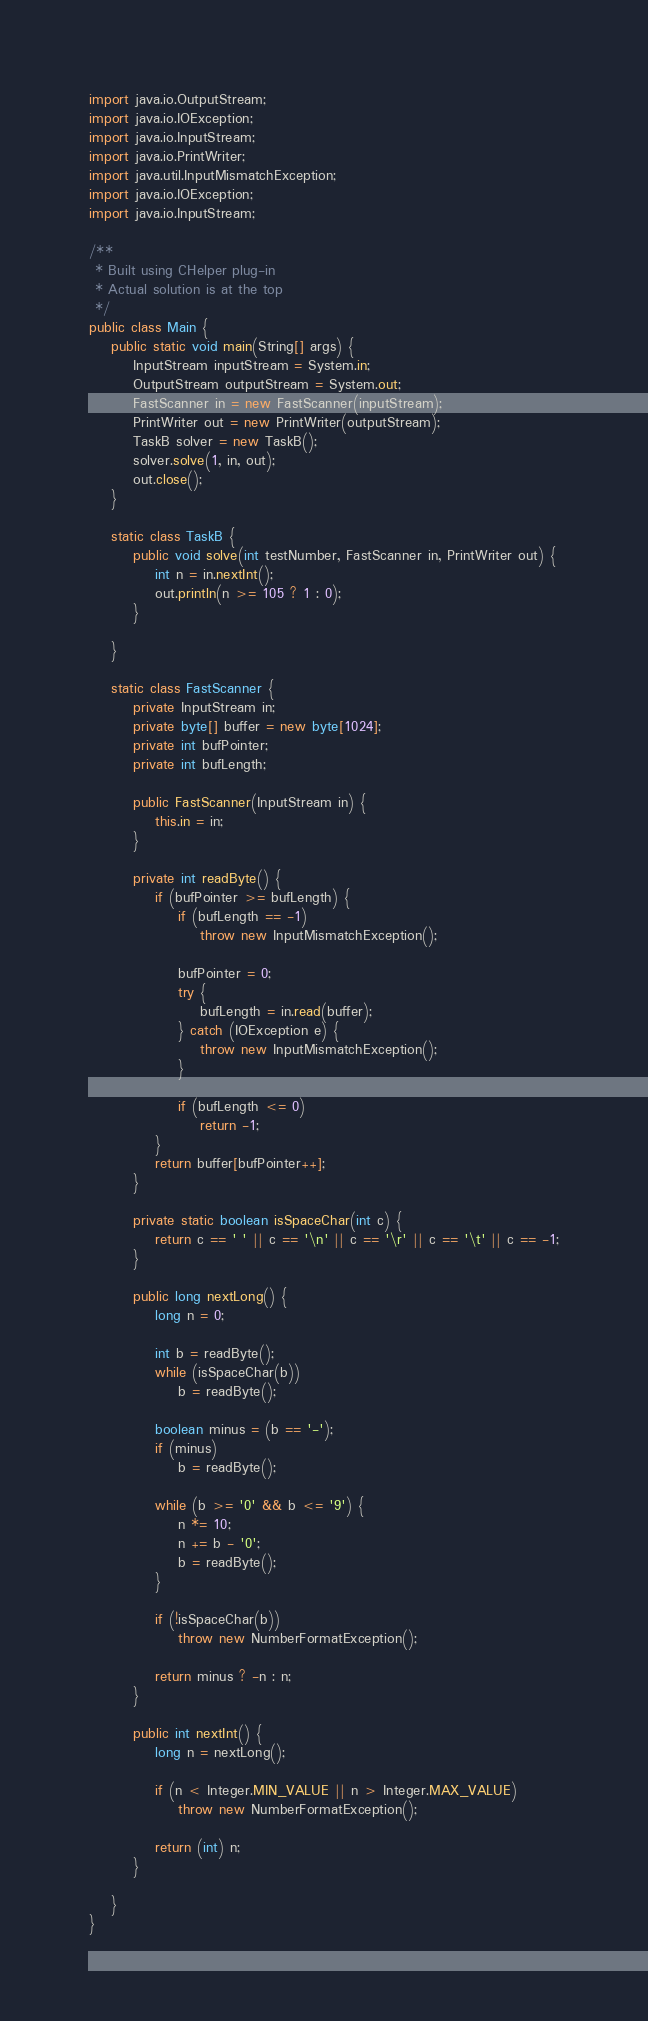Convert code to text. <code><loc_0><loc_0><loc_500><loc_500><_Java_>import java.io.OutputStream;
import java.io.IOException;
import java.io.InputStream;
import java.io.PrintWriter;
import java.util.InputMismatchException;
import java.io.IOException;
import java.io.InputStream;

/**
 * Built using CHelper plug-in
 * Actual solution is at the top
 */
public class Main {
    public static void main(String[] args) {
        InputStream inputStream = System.in;
        OutputStream outputStream = System.out;
        FastScanner in = new FastScanner(inputStream);
        PrintWriter out = new PrintWriter(outputStream);
        TaskB solver = new TaskB();
        solver.solve(1, in, out);
        out.close();
    }

    static class TaskB {
        public void solve(int testNumber, FastScanner in, PrintWriter out) {
            int n = in.nextInt();
            out.println(n >= 105 ? 1 : 0);
        }

    }

    static class FastScanner {
        private InputStream in;
        private byte[] buffer = new byte[1024];
        private int bufPointer;
        private int bufLength;

        public FastScanner(InputStream in) {
            this.in = in;
        }

        private int readByte() {
            if (bufPointer >= bufLength) {
                if (bufLength == -1)
                    throw new InputMismatchException();

                bufPointer = 0;
                try {
                    bufLength = in.read(buffer);
                } catch (IOException e) {
                    throw new InputMismatchException();
                }

                if (bufLength <= 0)
                    return -1;
            }
            return buffer[bufPointer++];
        }

        private static boolean isSpaceChar(int c) {
            return c == ' ' || c == '\n' || c == '\r' || c == '\t' || c == -1;
        }

        public long nextLong() {
            long n = 0;

            int b = readByte();
            while (isSpaceChar(b))
                b = readByte();

            boolean minus = (b == '-');
            if (minus)
                b = readByte();

            while (b >= '0' && b <= '9') {
                n *= 10;
                n += b - '0';
                b = readByte();
            }

            if (!isSpaceChar(b))
                throw new NumberFormatException();

            return minus ? -n : n;
        }

        public int nextInt() {
            long n = nextLong();

            if (n < Integer.MIN_VALUE || n > Integer.MAX_VALUE)
                throw new NumberFormatException();

            return (int) n;
        }

    }
}

</code> 